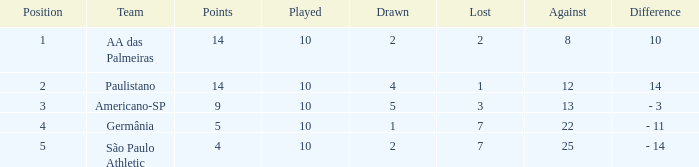Which team has a against greater than 8, lost of 7, and the ranking is 5? São Paulo Athletic. 